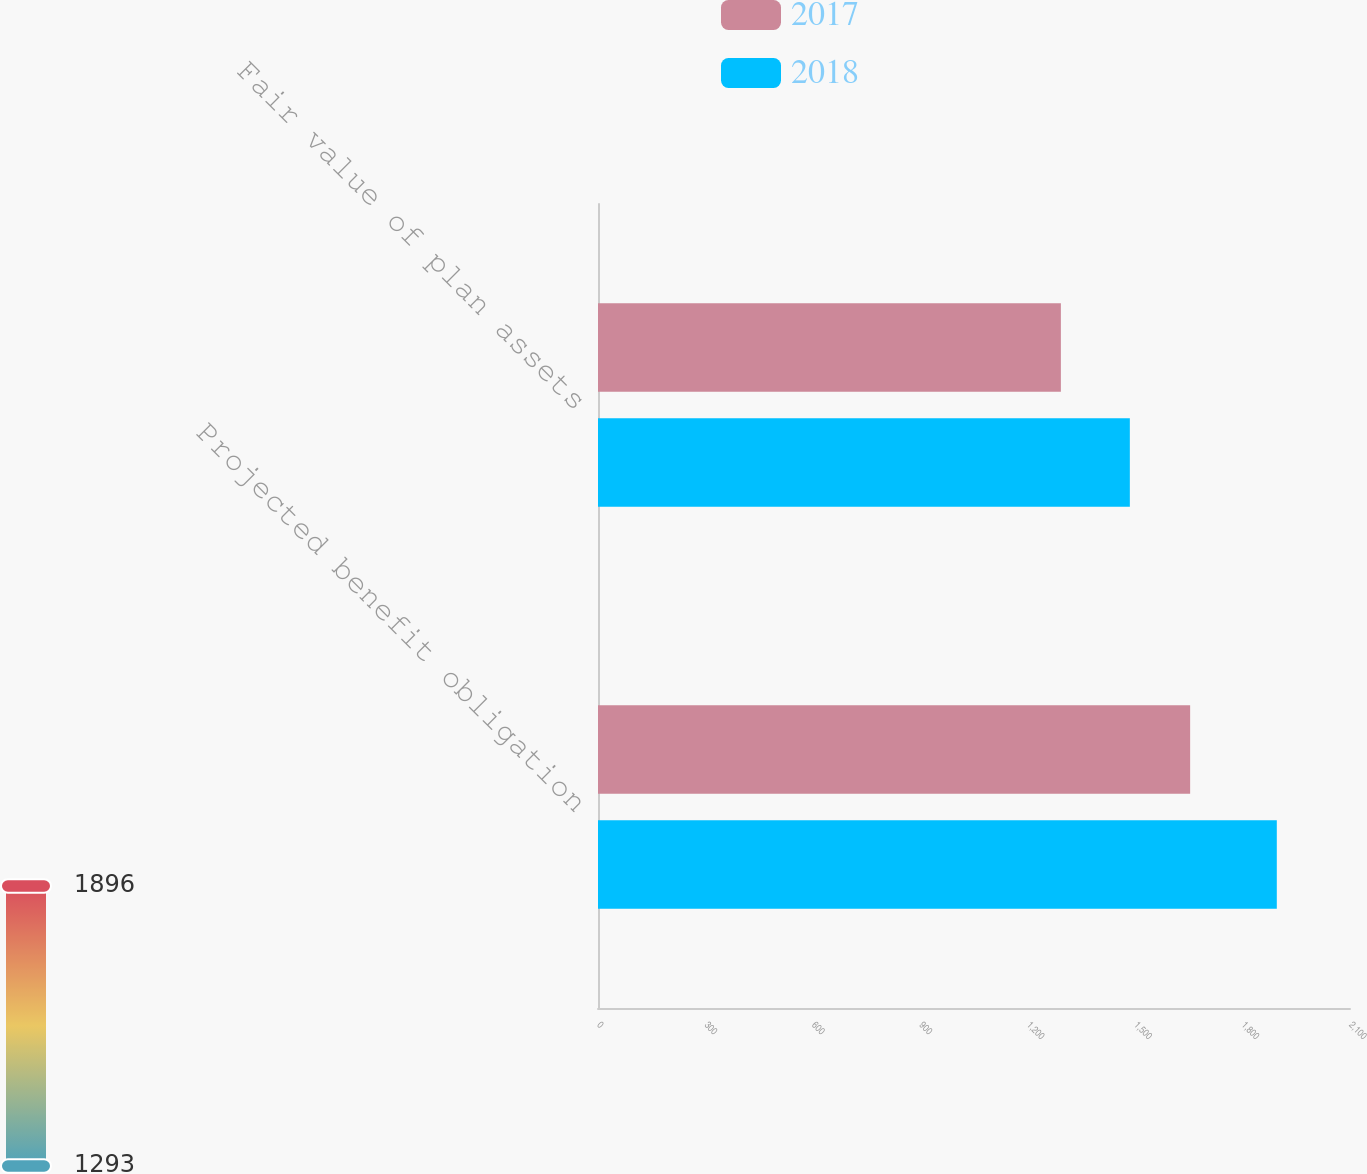Convert chart. <chart><loc_0><loc_0><loc_500><loc_500><stacked_bar_chart><ecel><fcel>Projected benefit obligation<fcel>Fair value of plan assets<nl><fcel>2017<fcel>1653.6<fcel>1292.6<nl><fcel>2018<fcel>1895.6<fcel>1485.2<nl></chart> 